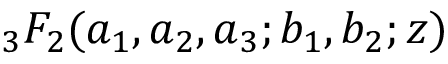Convert formula to latex. <formula><loc_0><loc_0><loc_500><loc_500>{ } _ { 3 } F _ { 2 } ( a _ { 1 } , a _ { 2 } , a _ { 3 } ; b _ { 1 } , b _ { 2 } ; z )</formula> 